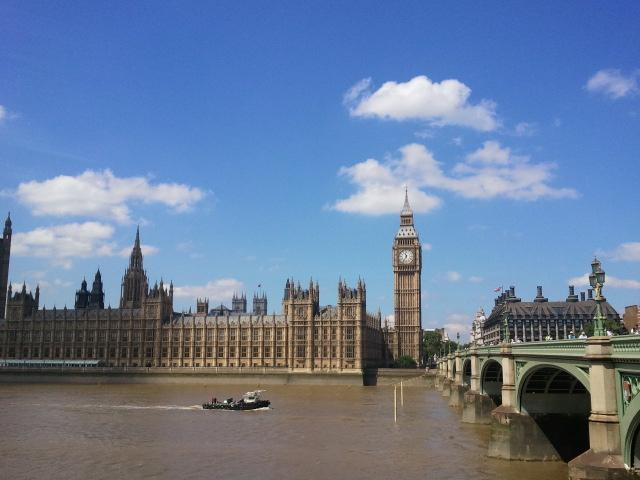What period of the day is shown in the image? morning 